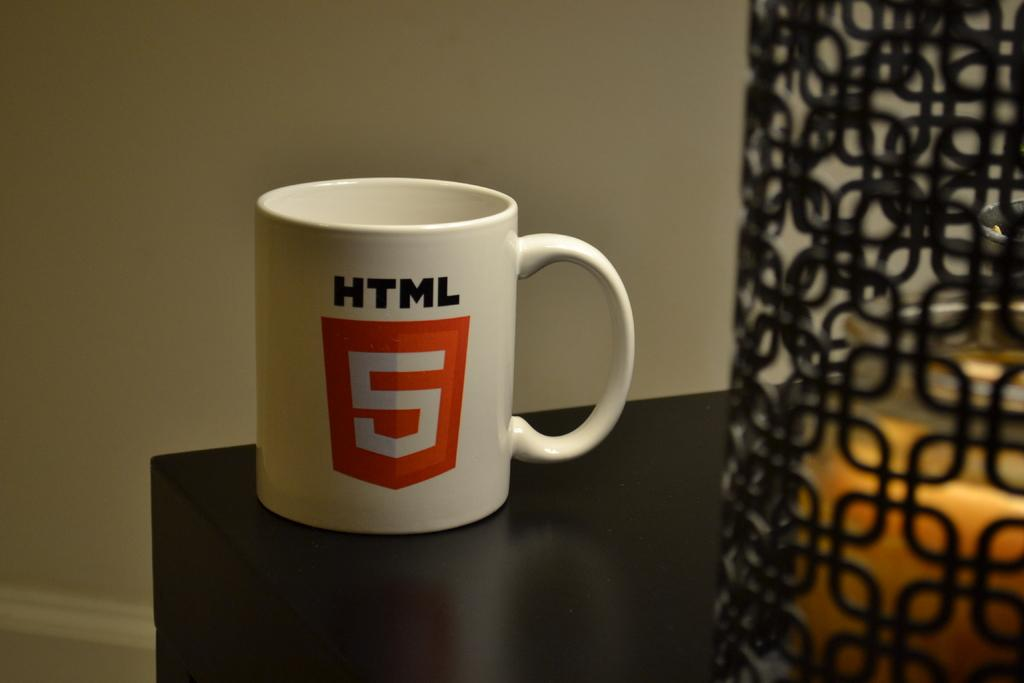Provide a one-sentence caption for the provided image. White HTML coffee cup with a red sheild with a 5 in white sitting on a dark brown table next to a lit candle. 